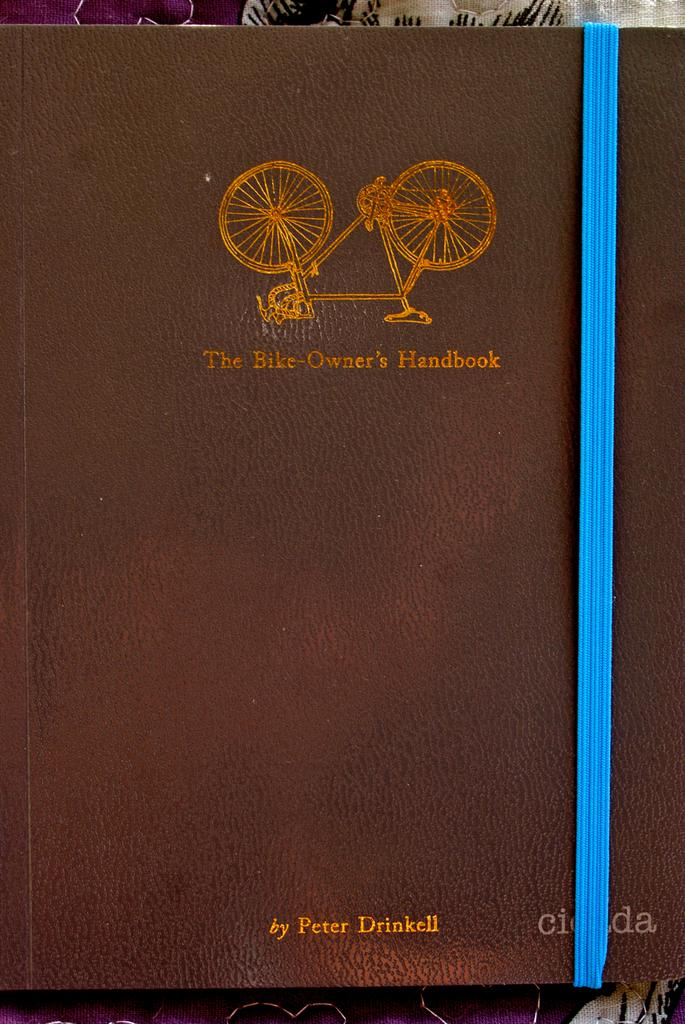Provide a one-sentence caption for the provided image. A leather bound book titled The Bike-Owner's Handbook. 